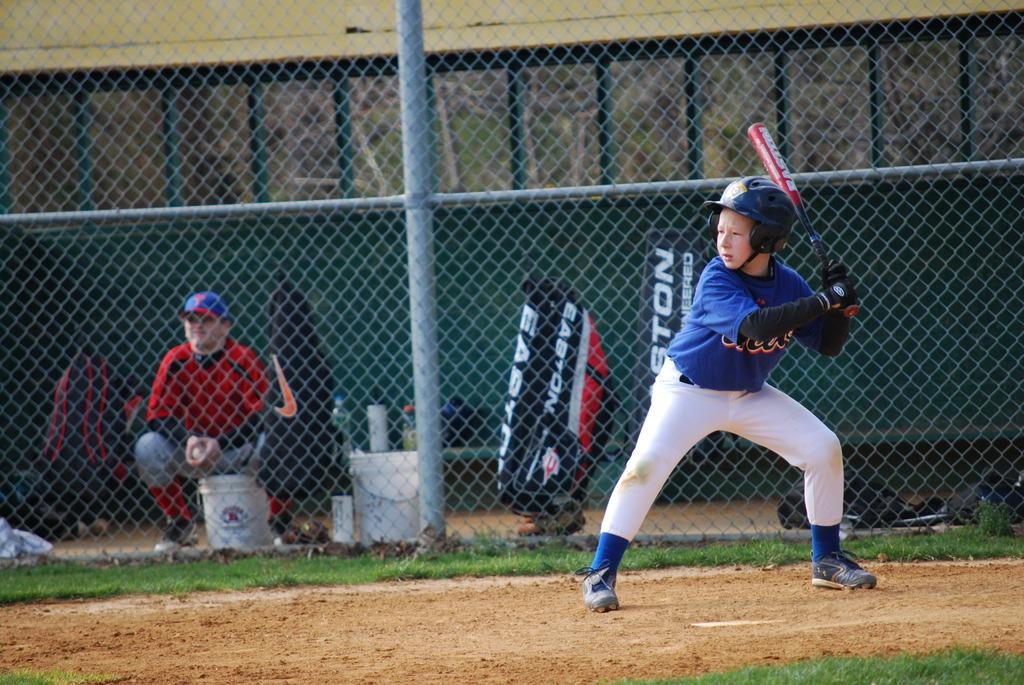<image>
Offer a succinct explanation of the picture presented. A young boy in a baseball uniform is at bat in front of a Easton bat bag. 